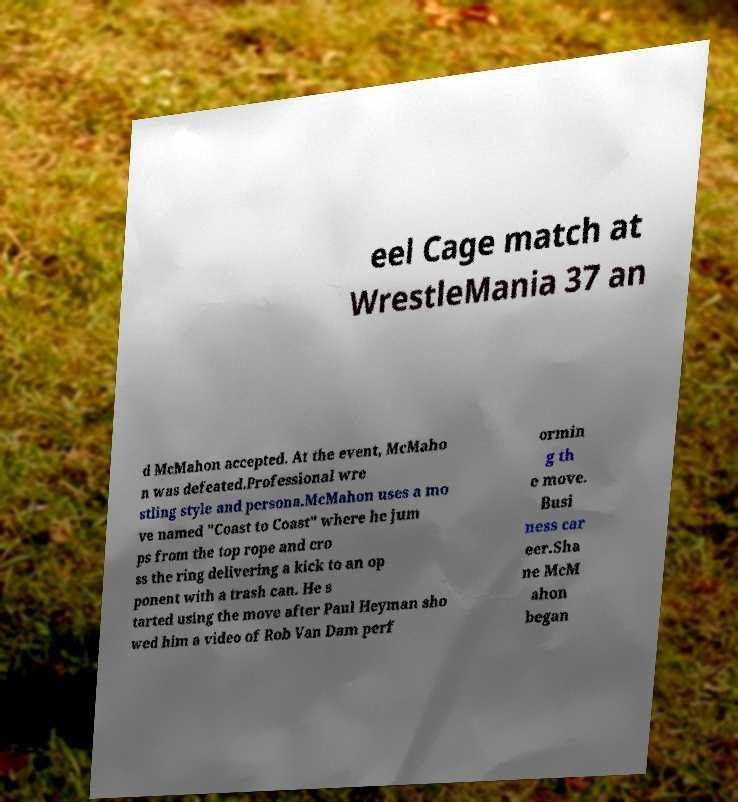Could you assist in decoding the text presented in this image and type it out clearly? eel Cage match at WrestleMania 37 an d McMahon accepted. At the event, McMaho n was defeated.Professional wre stling style and persona.McMahon uses a mo ve named "Coast to Coast" where he jum ps from the top rope and cro ss the ring delivering a kick to an op ponent with a trash can. He s tarted using the move after Paul Heyman sho wed him a video of Rob Van Dam perf ormin g th e move. Busi ness car eer.Sha ne McM ahon began 